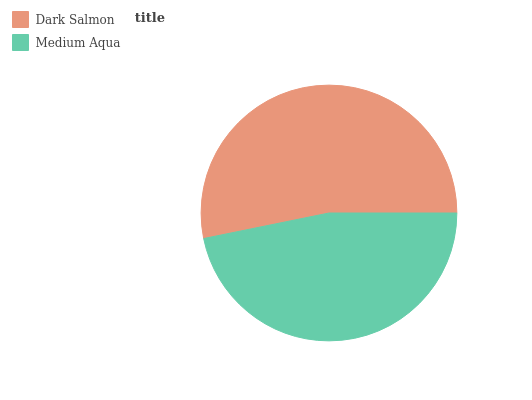Is Medium Aqua the minimum?
Answer yes or no. Yes. Is Dark Salmon the maximum?
Answer yes or no. Yes. Is Medium Aqua the maximum?
Answer yes or no. No. Is Dark Salmon greater than Medium Aqua?
Answer yes or no. Yes. Is Medium Aqua less than Dark Salmon?
Answer yes or no. Yes. Is Medium Aqua greater than Dark Salmon?
Answer yes or no. No. Is Dark Salmon less than Medium Aqua?
Answer yes or no. No. Is Dark Salmon the high median?
Answer yes or no. Yes. Is Medium Aqua the low median?
Answer yes or no. Yes. Is Medium Aqua the high median?
Answer yes or no. No. Is Dark Salmon the low median?
Answer yes or no. No. 